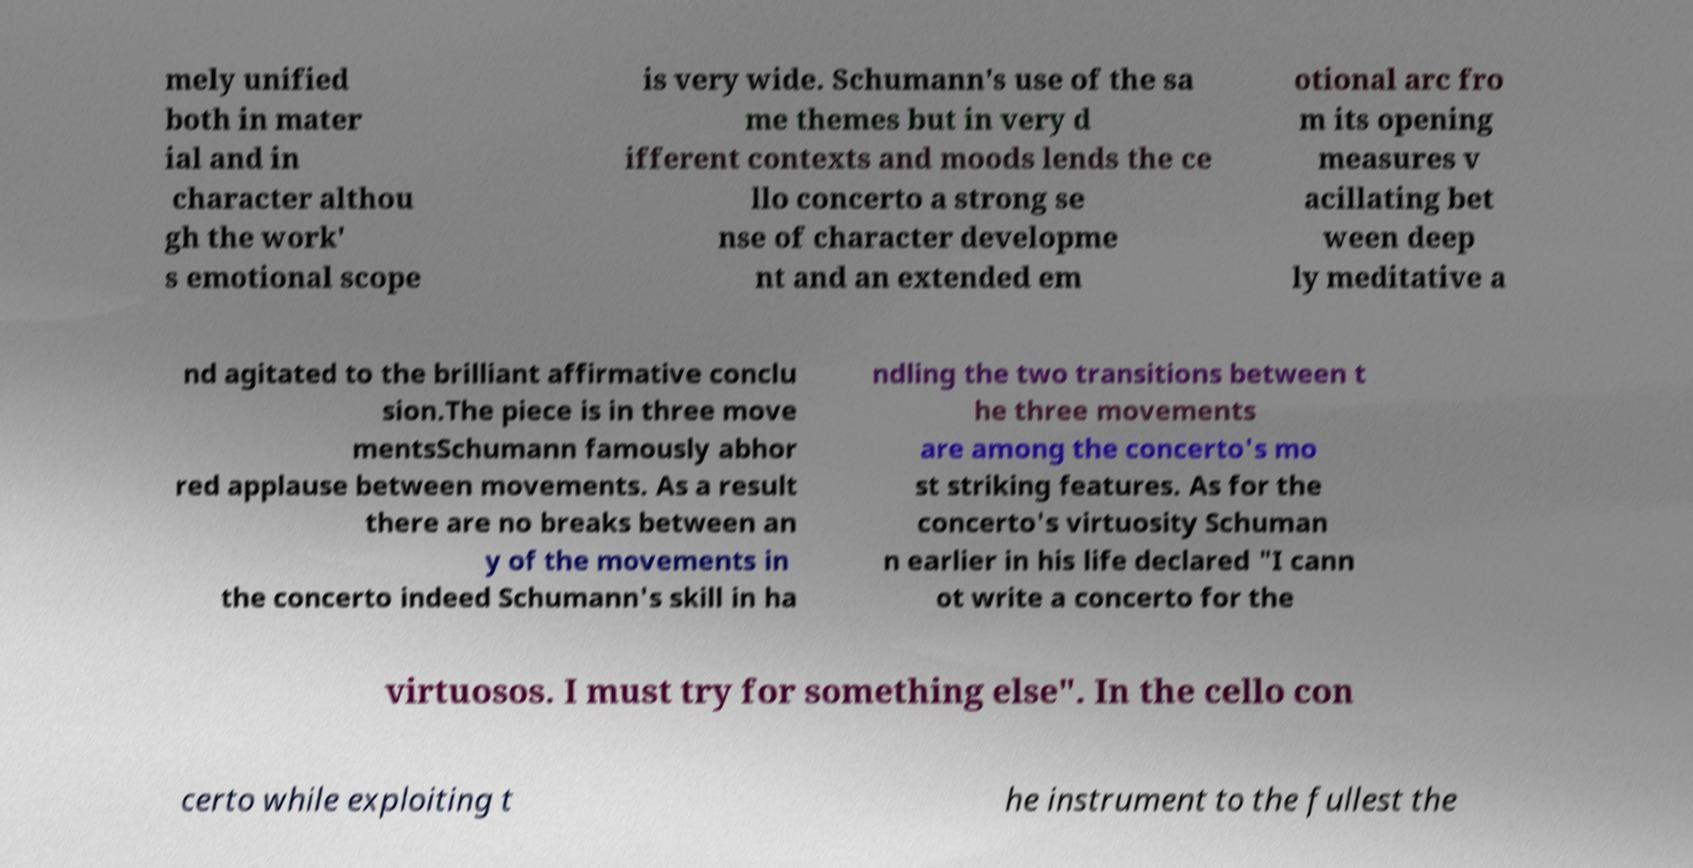What messages or text are displayed in this image? I need them in a readable, typed format. mely unified both in mater ial and in character althou gh the work' s emotional scope is very wide. Schumann's use of the sa me themes but in very d ifferent contexts and moods lends the ce llo concerto a strong se nse of character developme nt and an extended em otional arc fro m its opening measures v acillating bet ween deep ly meditative a nd agitated to the brilliant affirmative conclu sion.The piece is in three move mentsSchumann famously abhor red applause between movements. As a result there are no breaks between an y of the movements in the concerto indeed Schumann's skill in ha ndling the two transitions between t he three movements are among the concerto's mo st striking features. As for the concerto's virtuosity Schuman n earlier in his life declared "I cann ot write a concerto for the virtuosos. I must try for something else". In the cello con certo while exploiting t he instrument to the fullest the 